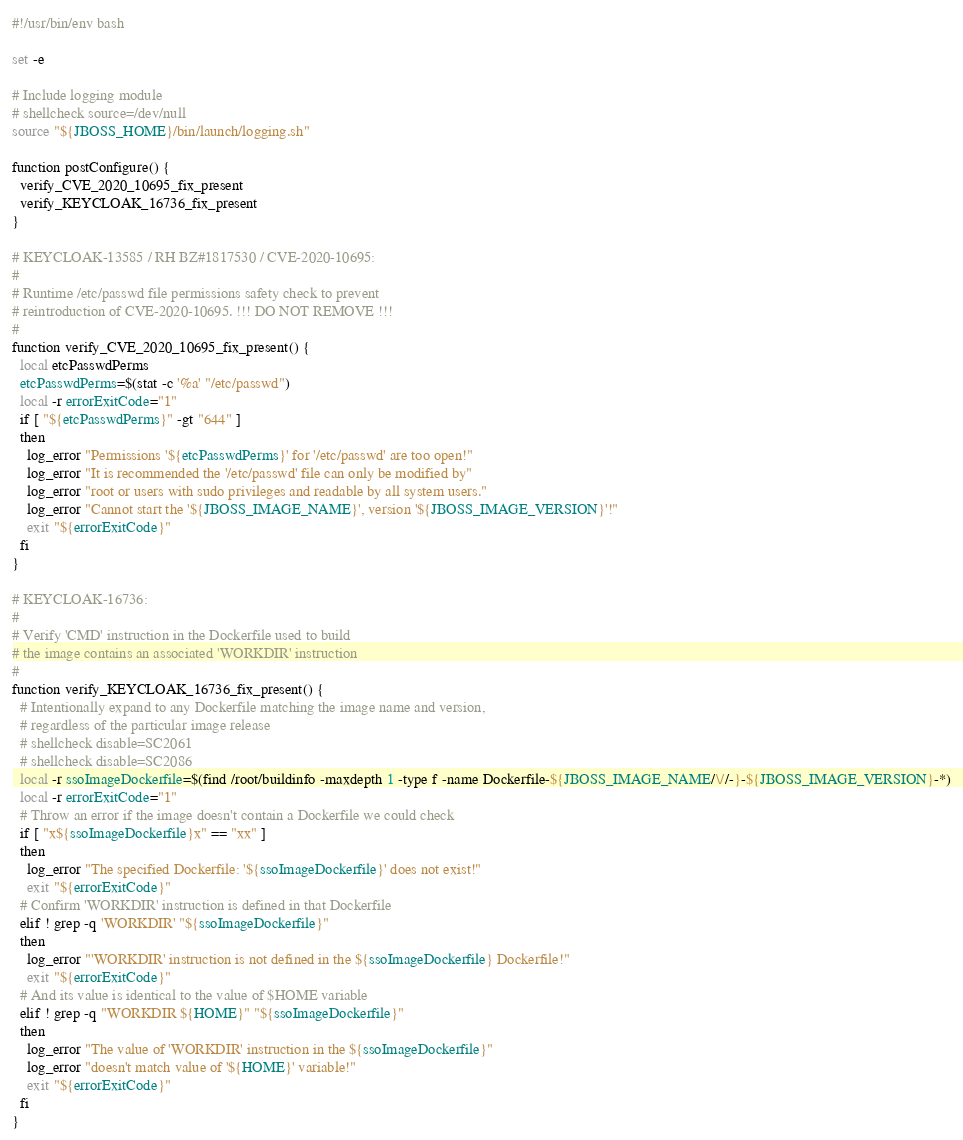<code> <loc_0><loc_0><loc_500><loc_500><_Bash_>#!/usr/bin/env bash

set -e

# Include logging module
# shellcheck source=/dev/null
source "${JBOSS_HOME}/bin/launch/logging.sh"

function postConfigure() {
  verify_CVE_2020_10695_fix_present
  verify_KEYCLOAK_16736_fix_present
}

# KEYCLOAK-13585 / RH BZ#1817530 / CVE-2020-10695:
#
# Runtime /etc/passwd file permissions safety check to prevent
# reintroduction of CVE-2020-10695. !!! DO NOT REMOVE !!!
#
function verify_CVE_2020_10695_fix_present() {
  local etcPasswdPerms
  etcPasswdPerms=$(stat -c '%a' "/etc/passwd")
  local -r errorExitCode="1"
  if [ "${etcPasswdPerms}" -gt "644" ]
  then
    log_error "Permissions '${etcPasswdPerms}' for '/etc/passwd' are too open!"
    log_error "It is recommended the '/etc/passwd' file can only be modified by"
    log_error "root or users with sudo privileges and readable by all system users."
    log_error "Cannot start the '${JBOSS_IMAGE_NAME}', version '${JBOSS_IMAGE_VERSION}'!"
    exit "${errorExitCode}"
  fi
}

# KEYCLOAK-16736:
#
# Verify 'CMD' instruction in the Dockerfile used to build
# the image contains an associated 'WORKDIR' instruction
#
function verify_KEYCLOAK_16736_fix_present() {
  # Intentionally expand to any Dockerfile matching the image name and version,
  # regardless of the particular image release
  # shellcheck disable=SC2061
  # shellcheck disable=SC2086
  local -r ssoImageDockerfile=$(find /root/buildinfo -maxdepth 1 -type f -name Dockerfile-${JBOSS_IMAGE_NAME/\//-}-${JBOSS_IMAGE_VERSION}-*)
  local -r errorExitCode="1"
  # Throw an error if the image doesn't contain a Dockerfile we could check
  if [ "x${ssoImageDockerfile}x" == "xx" ]
  then
    log_error "The specified Dockerfile: '${ssoImageDockerfile}' does not exist!"
    exit "${errorExitCode}"
  # Confirm 'WORKDIR' instruction is defined in that Dockerfile
  elif ! grep -q 'WORKDIR' "${ssoImageDockerfile}"
  then
    log_error "'WORKDIR' instruction is not defined in the ${ssoImageDockerfile} Dockerfile!"
    exit "${errorExitCode}"
  # And its value is identical to the value of $HOME variable
  elif ! grep -q "WORKDIR ${HOME}" "${ssoImageDockerfile}"
  then
    log_error "The value of 'WORKDIR' instruction in the ${ssoImageDockerfile}"
    log_error "doesn't match value of '${HOME}' variable!"
    exit "${errorExitCode}"
  fi
}
</code> 